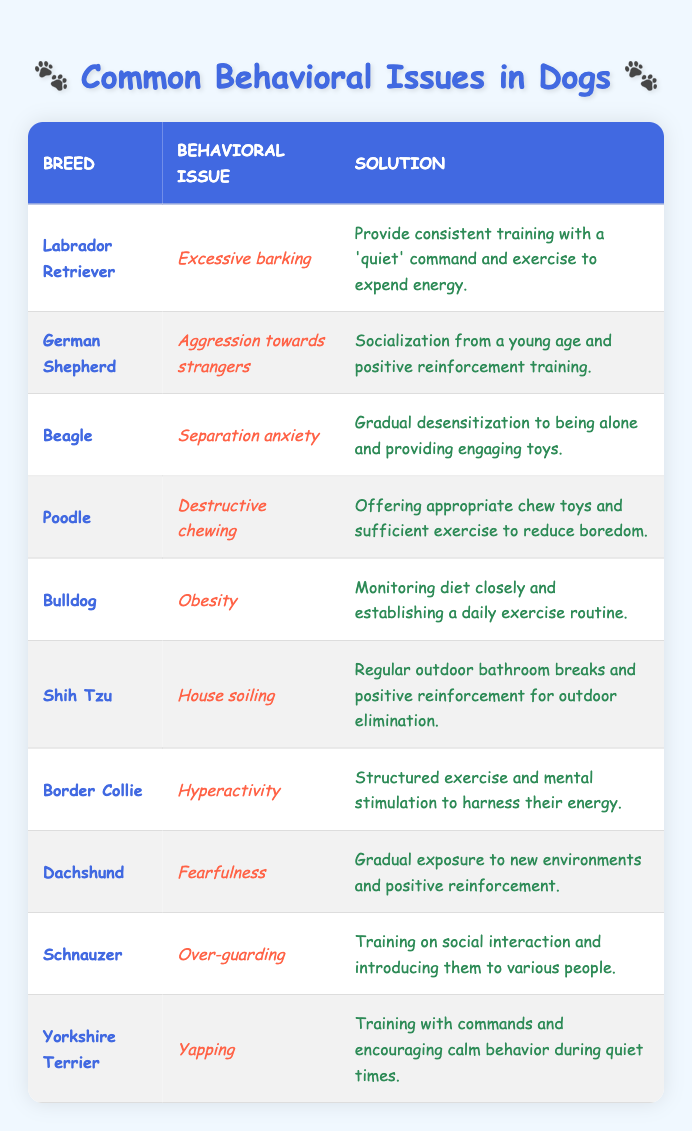What behavioral issue is associated with the Labrador Retriever? The table lists 'Excessive barking' under the 'Behavioral Issue' column for the Labrador Retriever breed.
Answer: Excessive barking Which breed has a solution involving socialization from a young age? The German Shepherd has the issue of 'Aggression towards strangers,' and the solution involves socialization from a young age.
Answer: German Shepherd How many breeds listed have issues related to anxiety? Only the Beagle has an issue related to anxiety, specifically 'Separation anxiety,' while no other breeds in the table have similar issues.
Answer: 1 Is there a breed listed that is known for hyperactivity? Yes, the Border Collie is known for the behavioral issue of 'Hyperactivity.'
Answer: Yes What is the solution for a Bulldog's obesity? The solution for a Bulldog's issue of obesity is 'Monitoring diet closely and establishing a daily exercise routine.'
Answer: Monitoring diet closely and establishing a daily exercise routine Which breeds require consistent training with a command to help with their behavioral issues? The Labrador Retriever requires consistent training with a 'quiet' command, and the Yorkshire Terrier requires training with commands to encourage calm behavior.
Answer: Labrador Retriever and Yorkshire Terrier What is the common behavioral issue shared by both the Dachshund and the Shih Tzu? Both the Dachshund and the Shih Tzu have behavioral issues related to their environment; the Dachshund has 'Fearfulness,' and the Shih Tzu has 'House soiling.' However, they do not share the same specific issue.
Answer: None What percentage of the breeds listed have issues related to guarding? There is only one breed listed with a guarding issue, the Schnauzer, out of ten breeds total. Therefore, the percentage is (1/10) * 100 = 10%.
Answer: 10% Which breeds need solutions involving mental stimulation? The Border Collie requires structured exercise and mental stimulation to harness their energy, which is mentioned in their solution.
Answer: Border Collie 